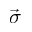Convert formula to latex. <formula><loc_0><loc_0><loc_500><loc_500>\vec { \sigma }</formula> 